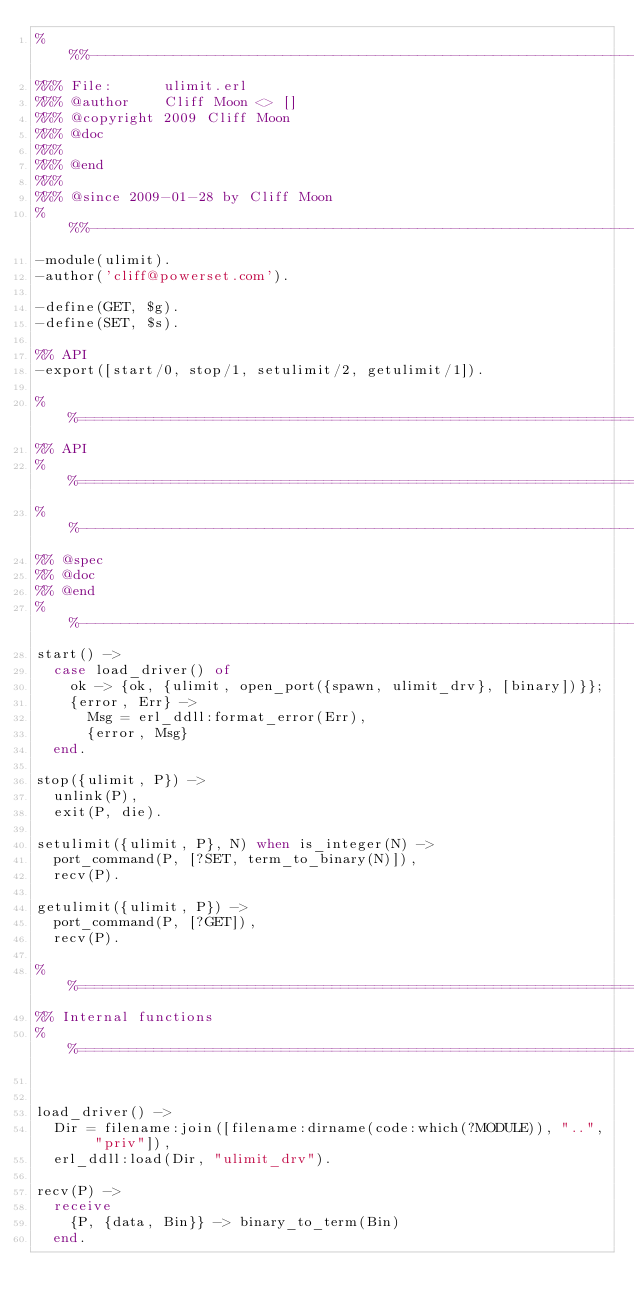<code> <loc_0><loc_0><loc_500><loc_500><_Erlang_>%%%-------------------------------------------------------------------
%%% File:      ulimit.erl
%%% @author    Cliff Moon <> []
%%% @copyright 2009 Cliff Moon
%%% @doc  
%%%
%%% @end  
%%%
%%% @since 2009-01-28 by Cliff Moon
%%%-------------------------------------------------------------------
-module(ulimit).
-author('cliff@powerset.com').

-define(GET, $g).
-define(SET, $s).

%% API
-export([start/0, stop/1, setulimit/2, getulimit/1]).

%%====================================================================
%% API
%%====================================================================
%%--------------------------------------------------------------------
%% @spec 
%% @doc
%% @end 
%%--------------------------------------------------------------------
start() ->
  case load_driver() of
    ok -> {ok, {ulimit, open_port({spawn, ulimit_drv}, [binary])}};
    {error, Err} ->
      Msg = erl_ddll:format_error(Err),
      {error, Msg}
  end.
  
stop({ulimit, P}) ->
  unlink(P),
  exit(P, die).
  
setulimit({ulimit, P}, N) when is_integer(N) ->
  port_command(P, [?SET, term_to_binary(N)]),
  recv(P).
  
getulimit({ulimit, P}) ->
  port_command(P, [?GET]),
  recv(P).
  
%%====================================================================
%% Internal functions
%%====================================================================


load_driver() ->
  Dir = filename:join([filename:dirname(code:which(?MODULE)), "..", "priv"]),
  erl_ddll:load(Dir, "ulimit_drv").

recv(P) ->
  receive
    {P, {data, Bin}} -> binary_to_term(Bin)
  end.</code> 